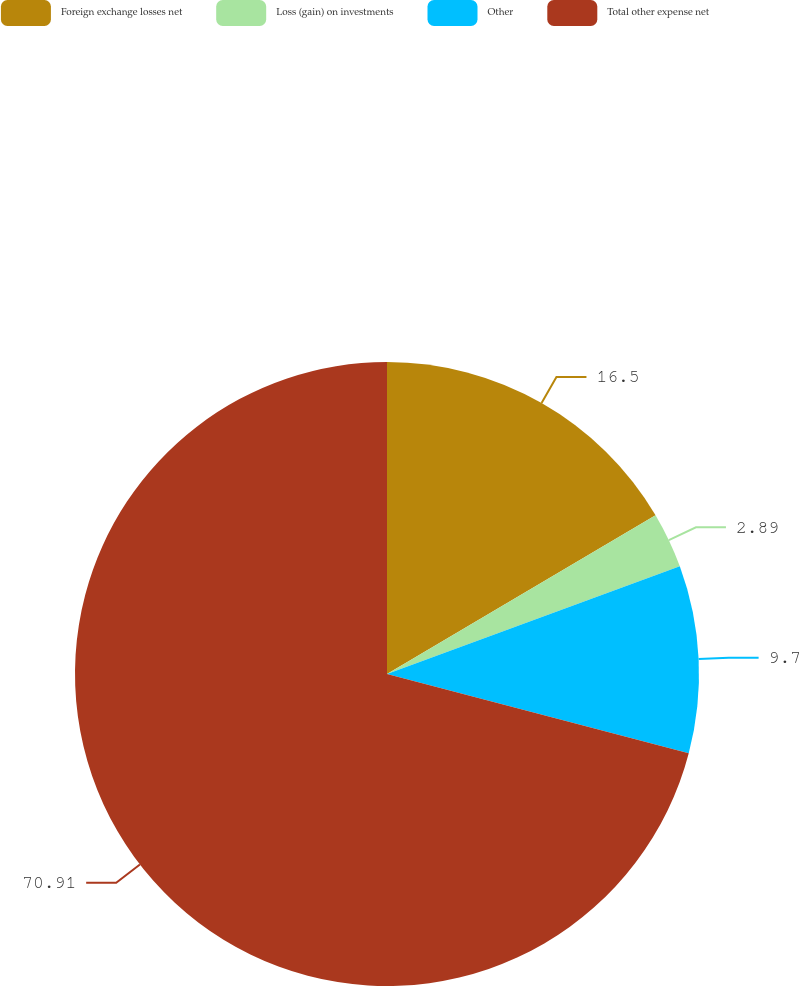<chart> <loc_0><loc_0><loc_500><loc_500><pie_chart><fcel>Foreign exchange losses net<fcel>Loss (gain) on investments<fcel>Other<fcel>Total other expense net<nl><fcel>16.5%<fcel>2.89%<fcel>9.7%<fcel>70.91%<nl></chart> 